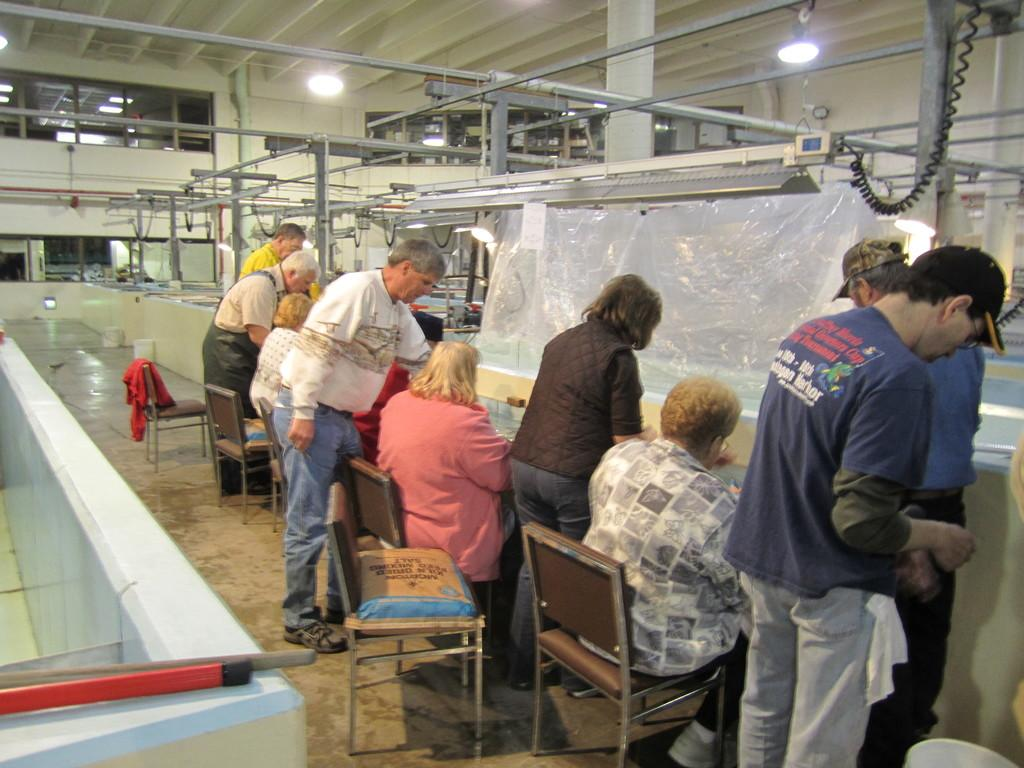What are the people in the image doing? The people in the image are sitting on a table and working. What can be seen in the background of the image? There are several machines in the background of the image. What type of news can be heard coming from the boats in the image? There are no boats present in the image, so it's not possible to determine what, if any, news might be heard. 